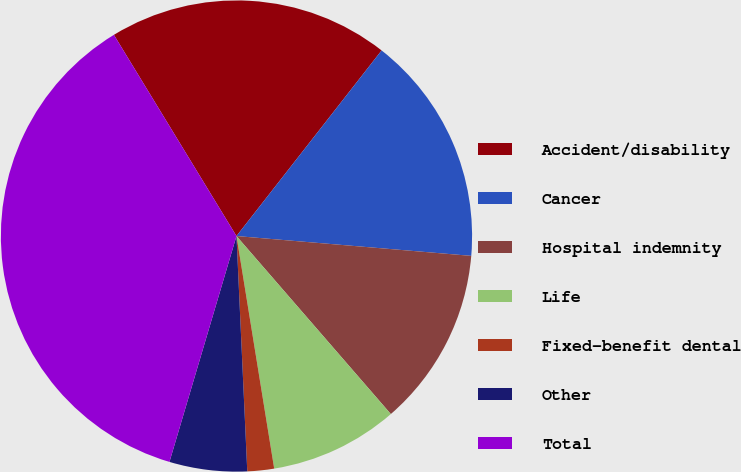<chart> <loc_0><loc_0><loc_500><loc_500><pie_chart><fcel>Accident/disability<fcel>Cancer<fcel>Hospital indemnity<fcel>Life<fcel>Fixed-benefit dental<fcel>Other<fcel>Total<nl><fcel>19.27%<fcel>15.78%<fcel>12.29%<fcel>8.81%<fcel>1.83%<fcel>5.32%<fcel>36.7%<nl></chart> 